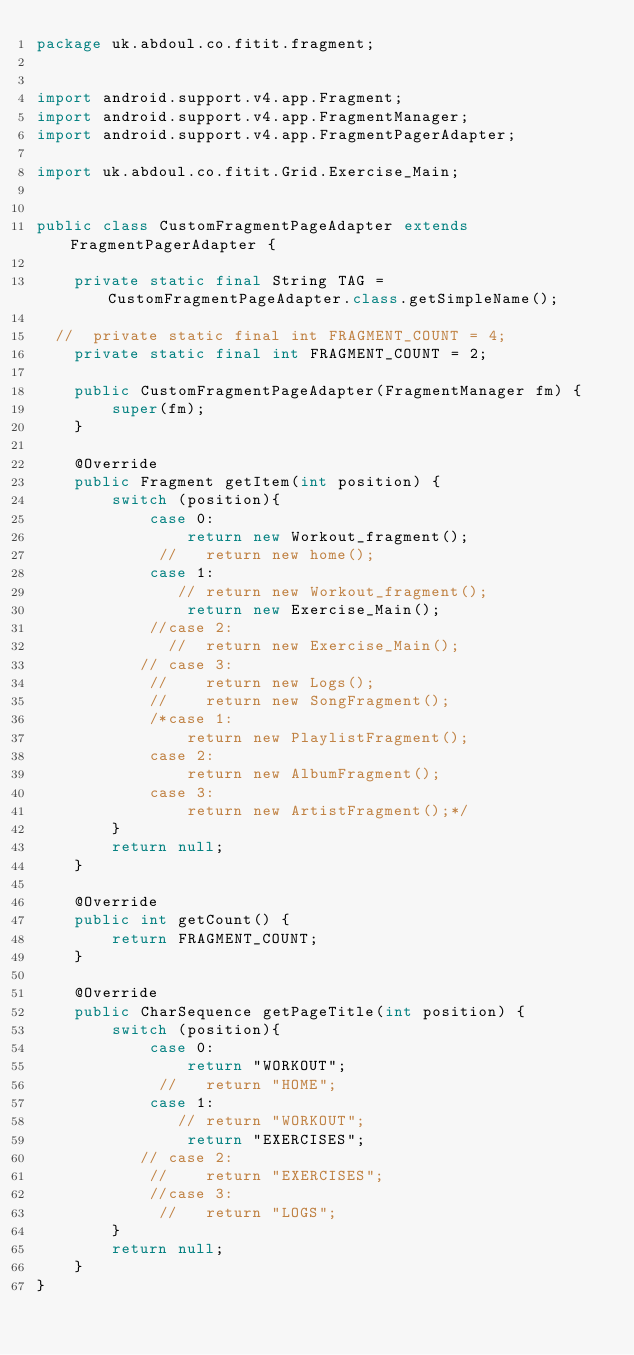Convert code to text. <code><loc_0><loc_0><loc_500><loc_500><_Java_>package uk.abdoul.co.fitit.fragment;


import android.support.v4.app.Fragment;
import android.support.v4.app.FragmentManager;
import android.support.v4.app.FragmentPagerAdapter;

import uk.abdoul.co.fitit.Grid.Exercise_Main;


public class CustomFragmentPageAdapter extends FragmentPagerAdapter {

    private static final String TAG = CustomFragmentPageAdapter.class.getSimpleName();

  //  private static final int FRAGMENT_COUNT = 4;
    private static final int FRAGMENT_COUNT = 2;

    public CustomFragmentPageAdapter(FragmentManager fm) {
        super(fm);
    }

    @Override
    public Fragment getItem(int position) {
        switch (position){
            case 0:
                return new Workout_fragment();
             //   return new home();
            case 1:
               // return new Workout_fragment();
                return new Exercise_Main();
            //case 2:
              //  return new Exercise_Main();
           // case 3:
            //    return new Logs();
            //    return new SongFragment();
            /*case 1:
                return new PlaylistFragment();
            case 2:
                return new AlbumFragment();
            case 3:
                return new ArtistFragment();*/
        }
        return null;
    }

    @Override
    public int getCount() {
        return FRAGMENT_COUNT;
    }

    @Override
    public CharSequence getPageTitle(int position) {
        switch (position){
            case 0:
                return "WORKOUT";
             //   return "HOME";
            case 1:
               // return "WORKOUT";
                return "EXERCISES";
           // case 2:
            //    return "EXERCISES";
            //case 3:
             //   return "LOGS";
        }
        return null;
    }
}
</code> 